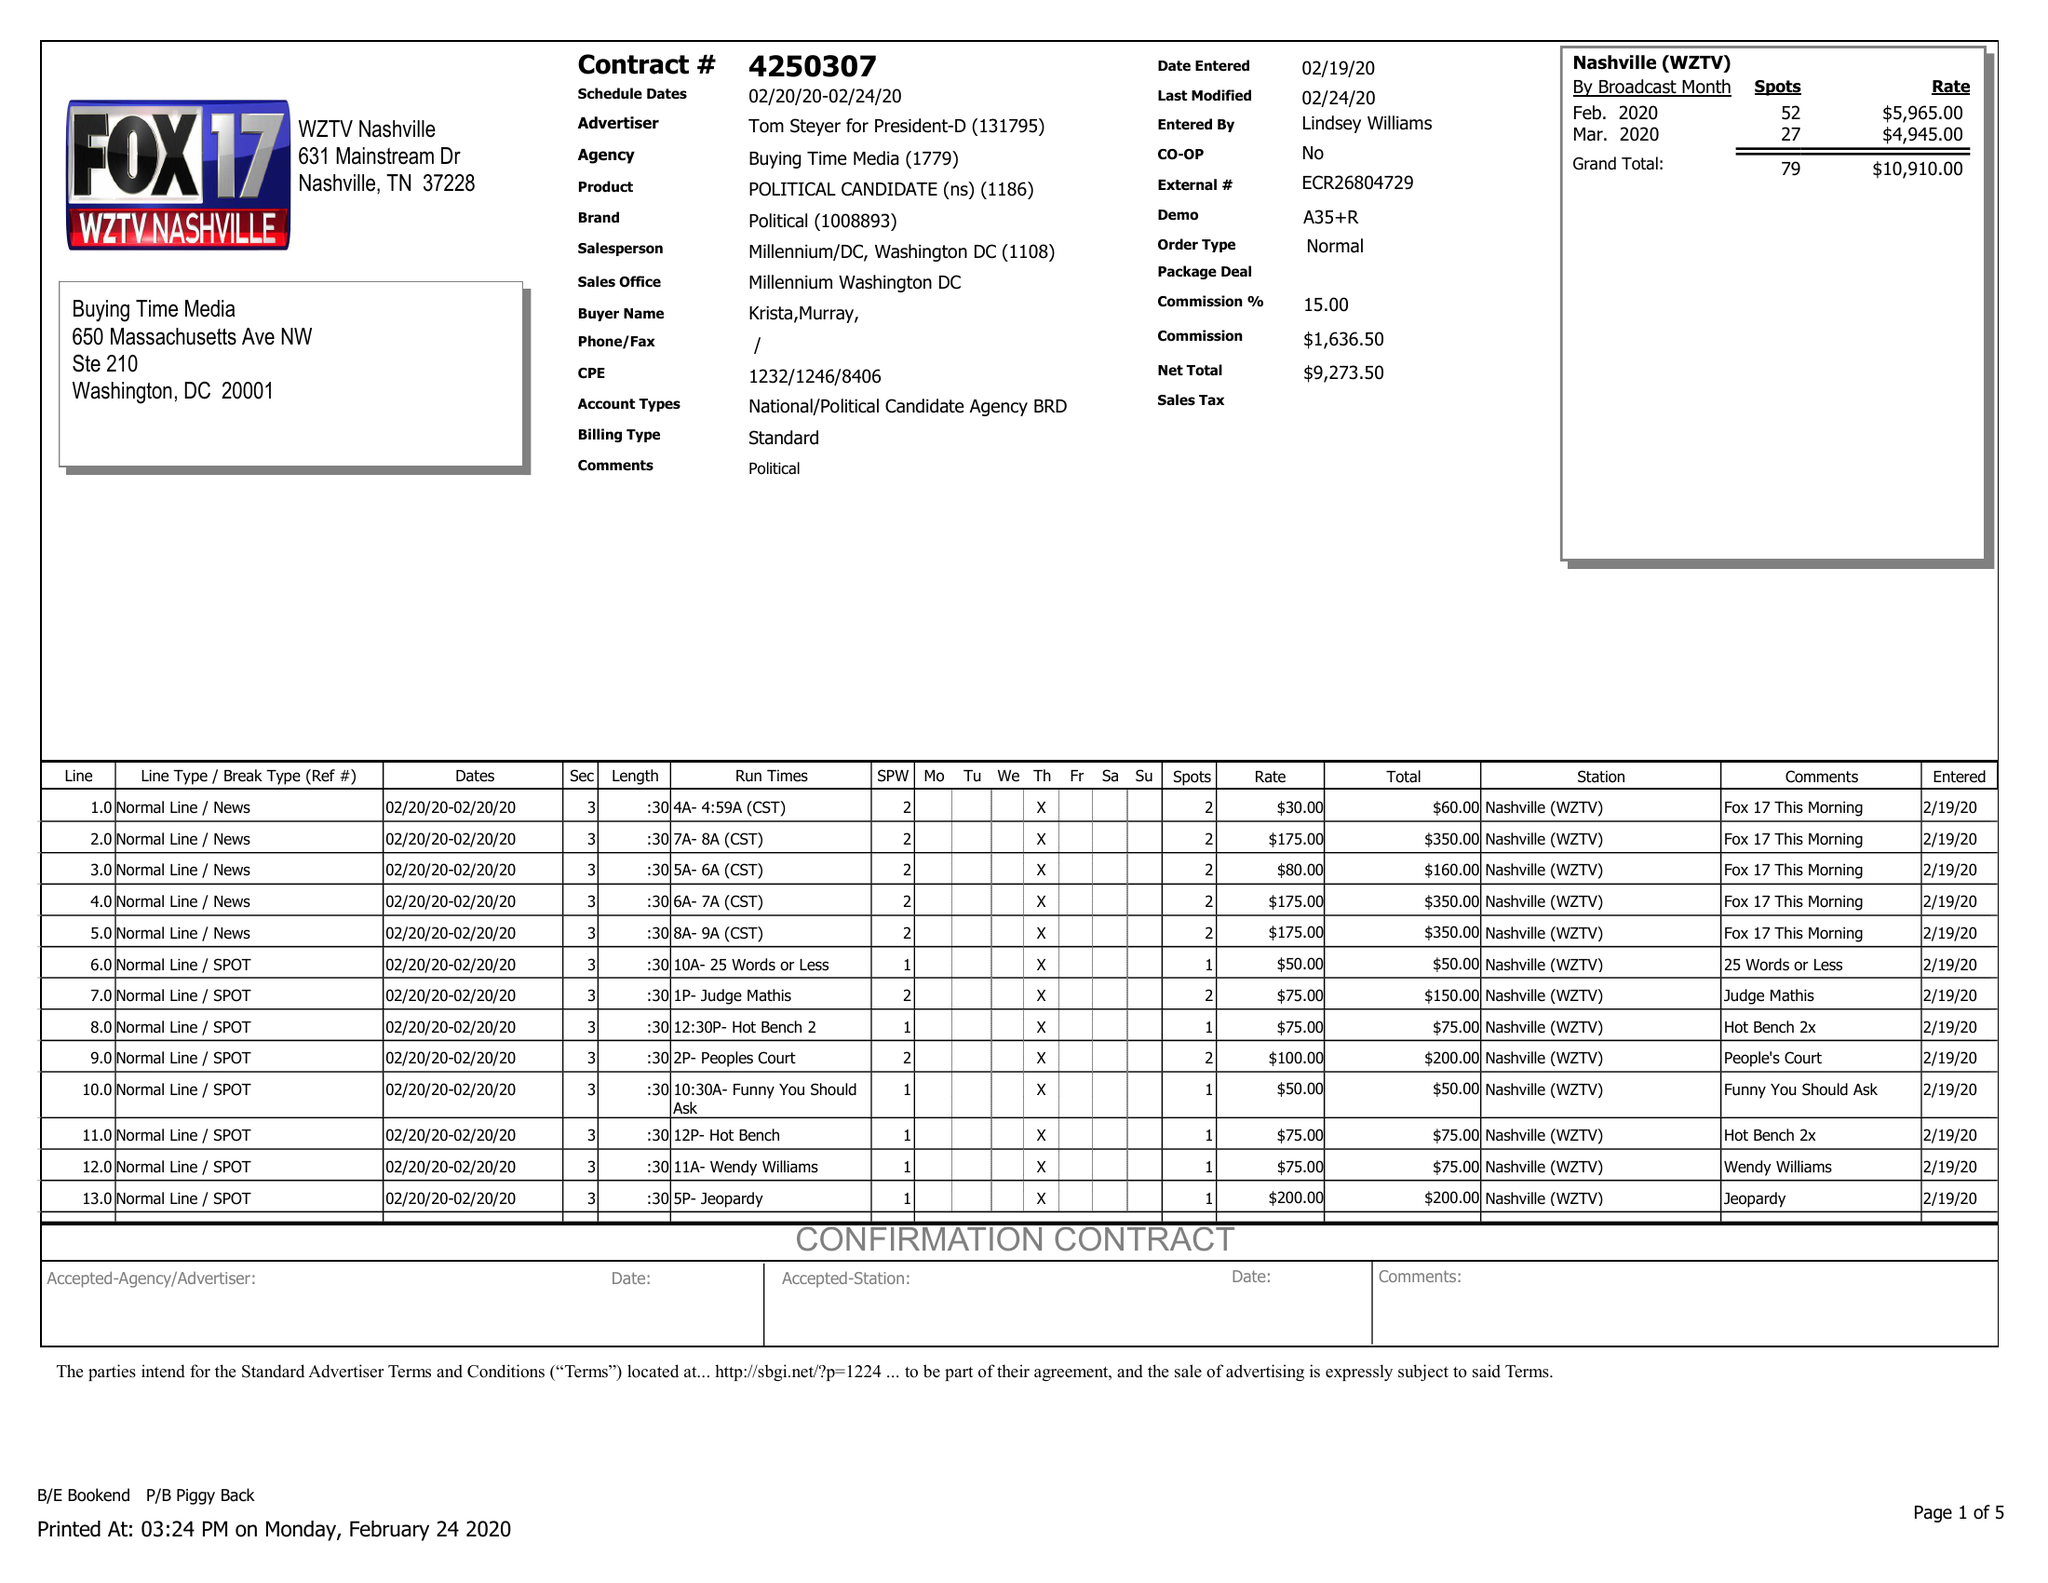What is the value for the contract_num?
Answer the question using a single word or phrase. 4250307 